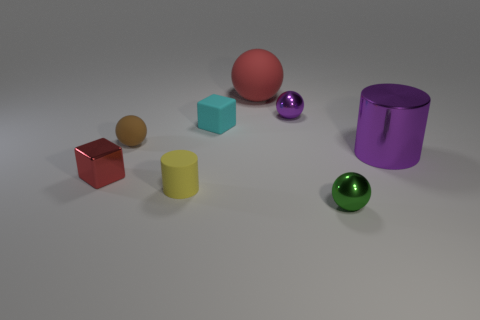Explain the lighting of the scene. The lighting in the scene appears to be diffuse with soft shadows, suggesting an overhead light source. The shadows indicate the light source is located slightly to the left of the center. 